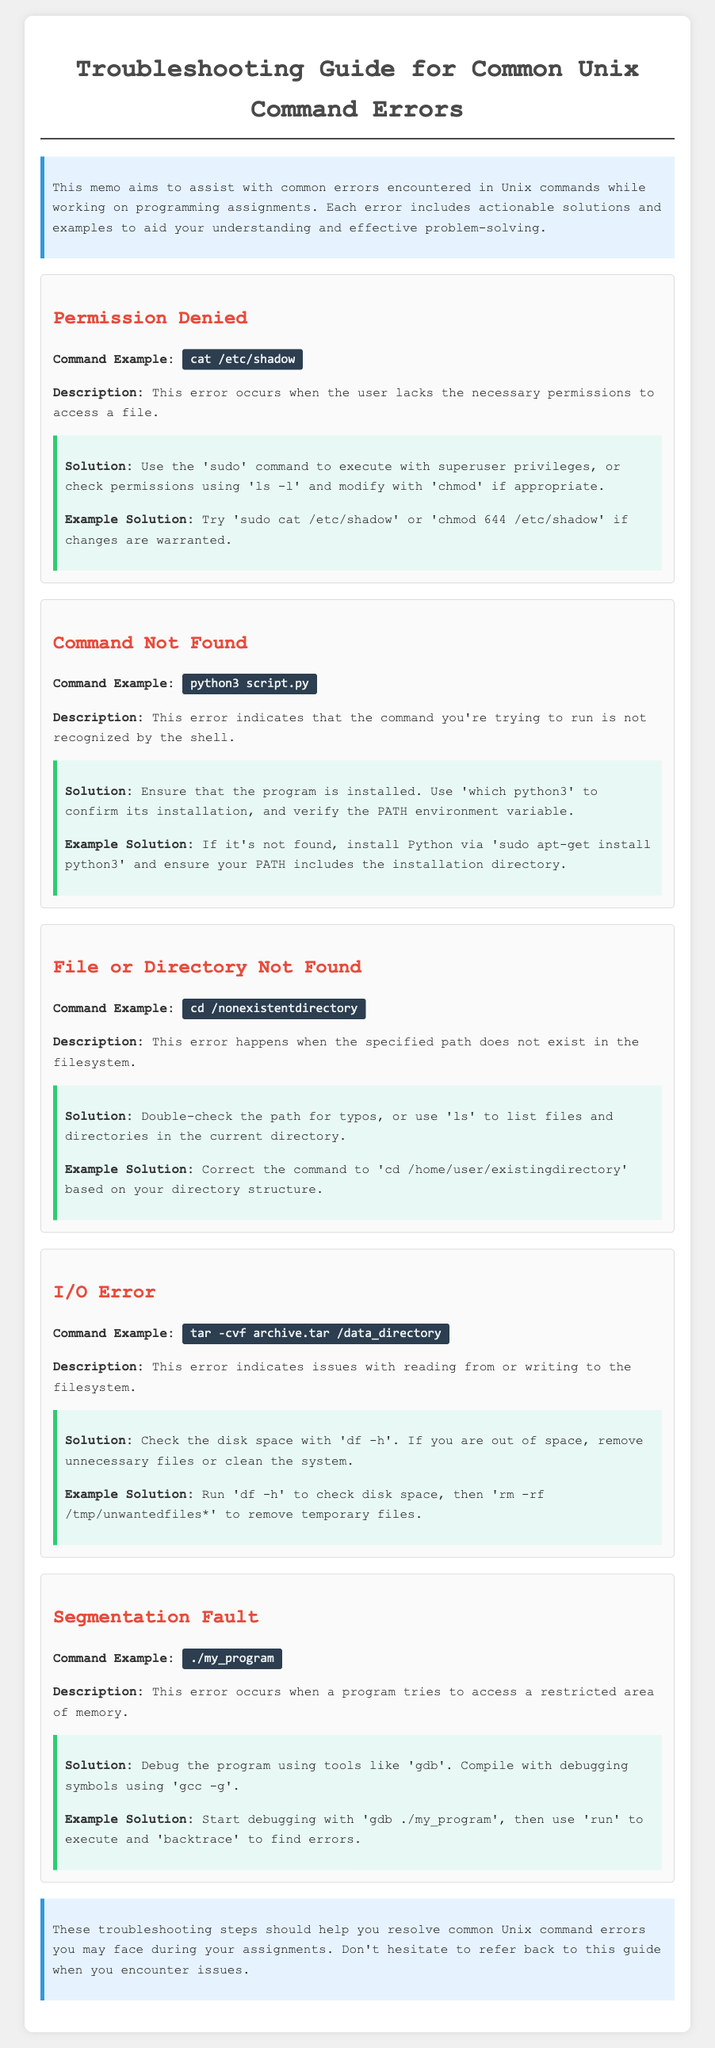What is the title of the document? The title is presented prominently at the top of the document and is "Troubleshooting Guide for Common Unix Command Errors."
Answer: Troubleshooting Guide for Common Unix Command Errors What is a common error when accessing files? The document lists "Permission Denied" as one of the common errors encountered in Unix commands.
Answer: Permission Denied What command is used to check permissions? The document mentions the command 'ls -l' for checking file permissions.
Answer: ls -l What should you do to resolve a "Command Not Found" error? The solution suggests ensuring the program is installed and using 'which python3' to confirm its installation.
Answer: Ensure the program is installed What error occurs when a program accesses restricted memory? The document refers to this type of error as a "Segmentation Fault."
Answer: Segmentation Fault Which command is shown as an example for an input/output error? The example command provided in the document for an input/output error is 'tar -cvf archive.tar /data_directory.'
Answer: tar -cvf archive.tar /data_directory What tool can help debug a program? The document recommends using 'gdb' as a tool for debugging programs.
Answer: gdb What is the suggested command to check disk space? The document instructs users to run 'df -h' to check the available disk space.
Answer: df -h What is mentioned as a potential solution for a "File or Directory Not Found" error? The document suggests double-checking the path for typos or using 'ls' to list files.
Answer: Check the path for typos 